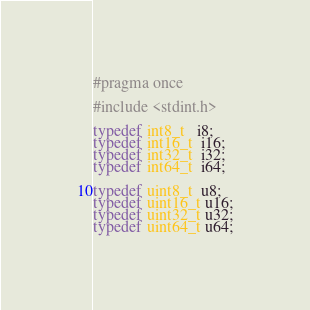<code> <loc_0><loc_0><loc_500><loc_500><_C_>#pragma once

#include <stdint.h>

typedef int8_t   i8;
typedef int16_t  i16;
typedef int32_t  i32;
typedef int64_t  i64;

typedef uint8_t  u8;
typedef uint16_t u16;
typedef uint32_t u32;
typedef uint64_t u64;
</code> 